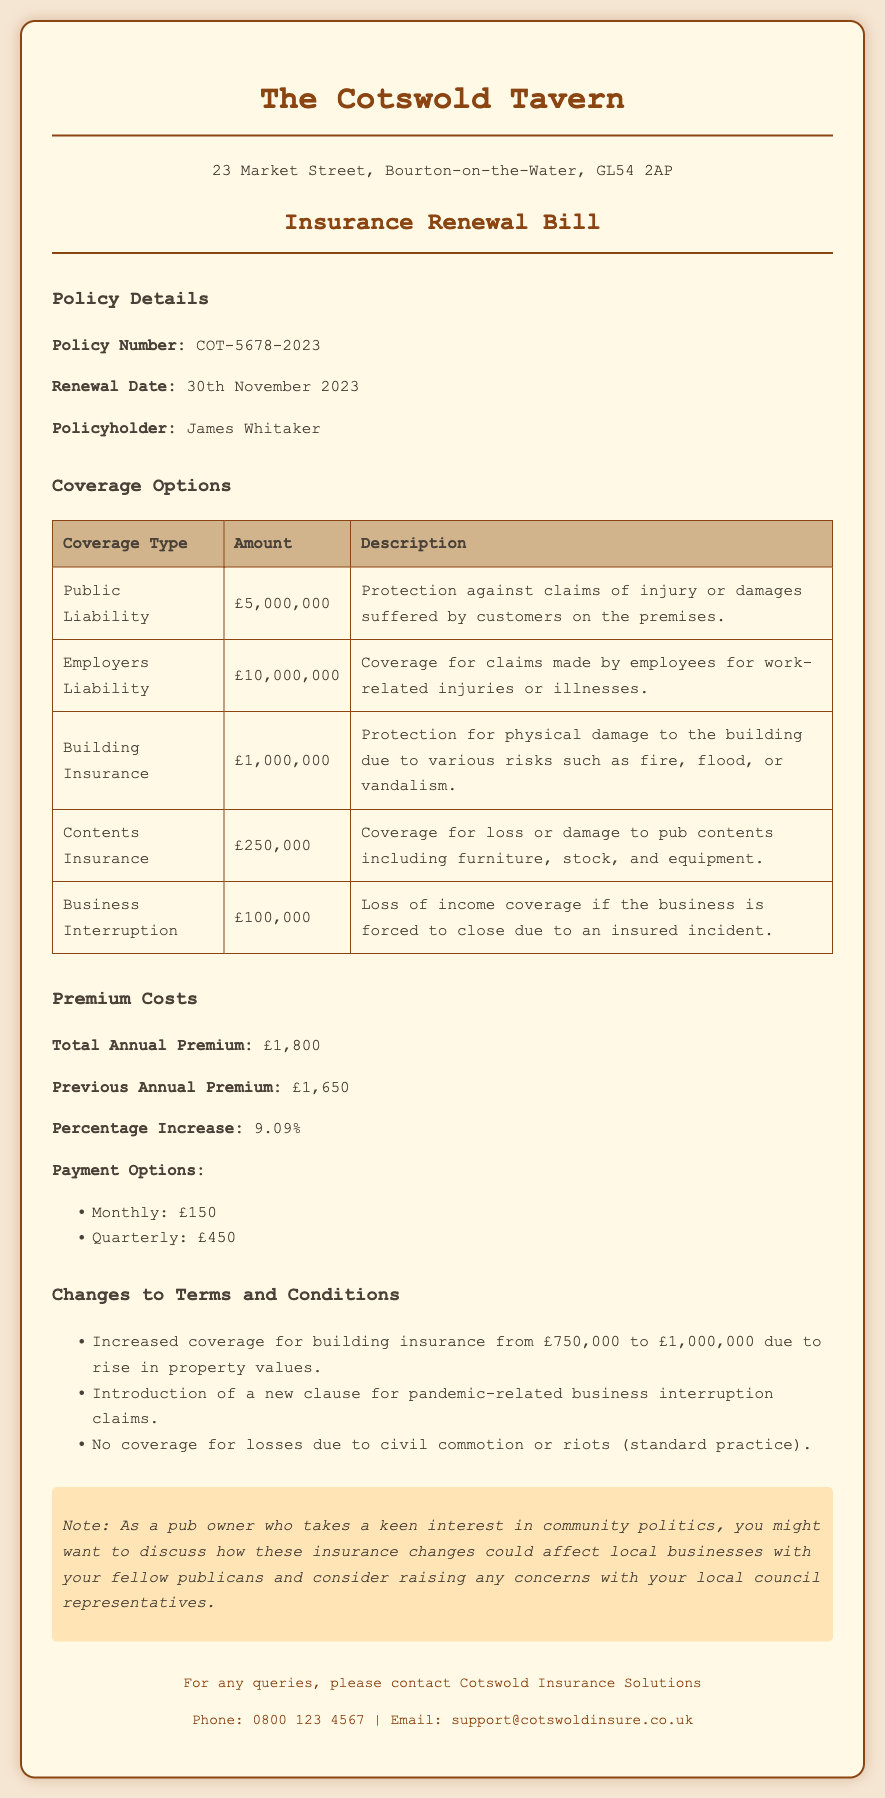What is the policy number? The policy number is explicitly stated in the policy details section of the document.
Answer: COT-5678-2023 When is the renewal date? The renewal date is provided under the policy details section.
Answer: 30th November 2023 What is the total annual premium? The total annual premium is listed in the premium costs section.
Answer: £1,800 How much is the public liability coverage? The amount for public liability coverage is mentioned in the coverage options table.
Answer: £5,000,000 What was the percentage increase in the premium? The percentage increase is calculated based on the previous and current premium, shown in the premium costs section.
Answer: 9.09% What has changed in the building insurance coverage? The document specifies changes made in terms of the coverage amount for building insurance.
Answer: Increased from £750,000 to £1,000,000 Is there coverage for losses due to civil commotion? The changes section mentions the policy regarding civil commotion losses.
Answer: No coverage What is the amount for employers liability coverage? The employers liability coverage amount is detailed in the coverage options table.
Answer: £10,000,000 What is the contact number for Cotswold Insurance Solutions? The contact number is provided at the bottom of the document in the footer section.
Answer: 0800 123 4567 